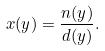Convert formula to latex. <formula><loc_0><loc_0><loc_500><loc_500>x ( y ) = \frac { n ( y ) } { d ( y ) } .</formula> 